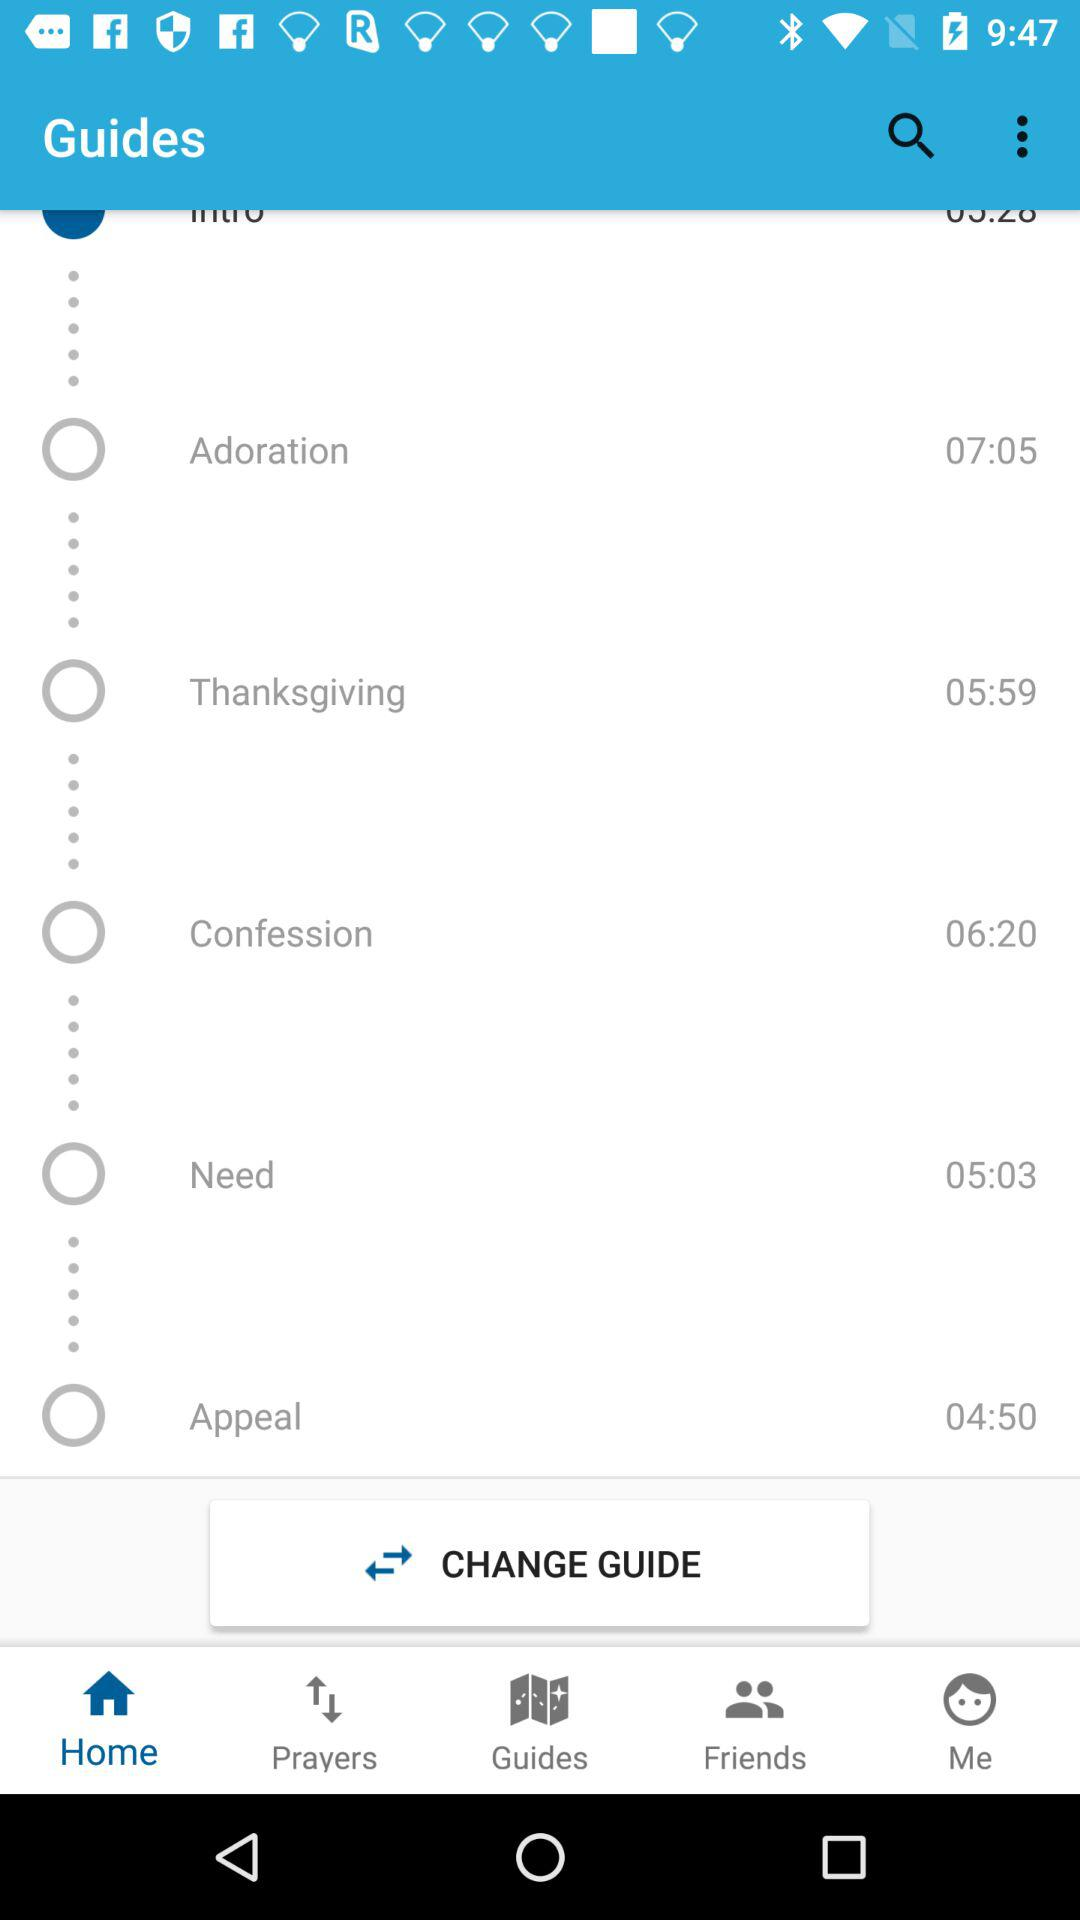Which tab is selected? The selected tab is "Home". 